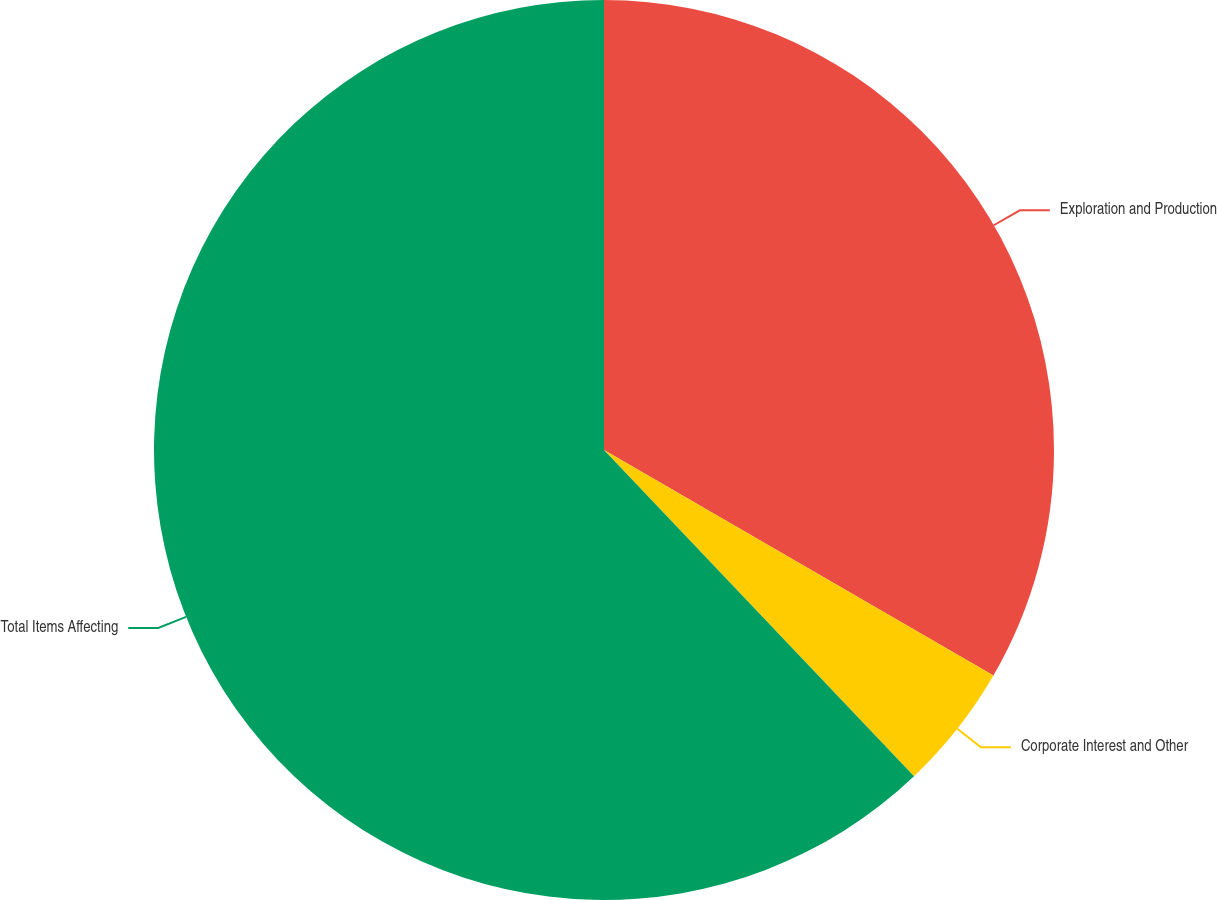Convert chart to OTSL. <chart><loc_0><loc_0><loc_500><loc_500><pie_chart><fcel>Exploration and Production<fcel>Corporate Interest and Other<fcel>Total Items Affecting<nl><fcel>33.35%<fcel>4.55%<fcel>62.09%<nl></chart> 